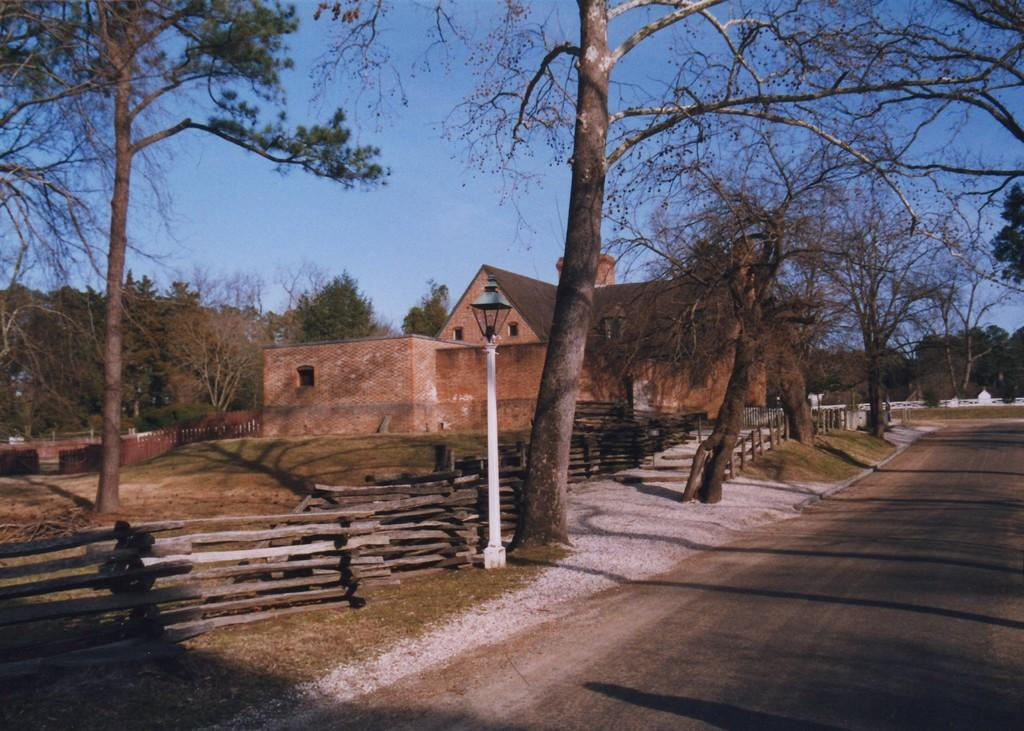What type of structure is visible in the image? There is a house in the image. What are some of the features of the house's surroundings? There are walls, a street light, trees, fences, grass, plants, and a road visible in the image. Can you describe the road in the image? The road is visible in the background of the image. What type of heart can be seen beating in the image? There is no heart visible in the image. Can you describe the crow perched on the roof of the house in the image? There is no crow present in the image. 